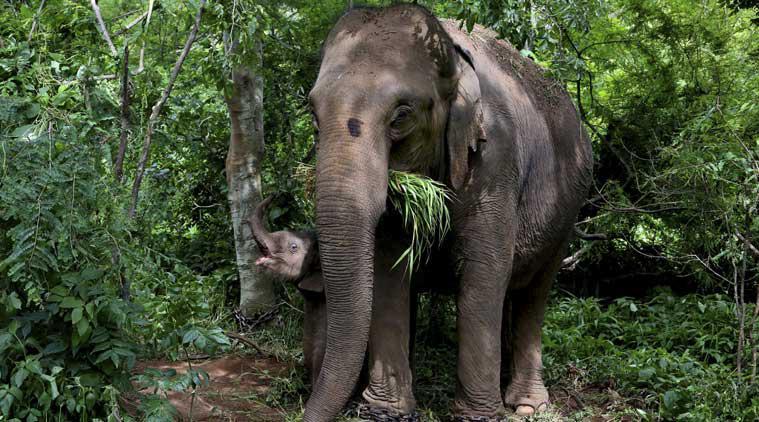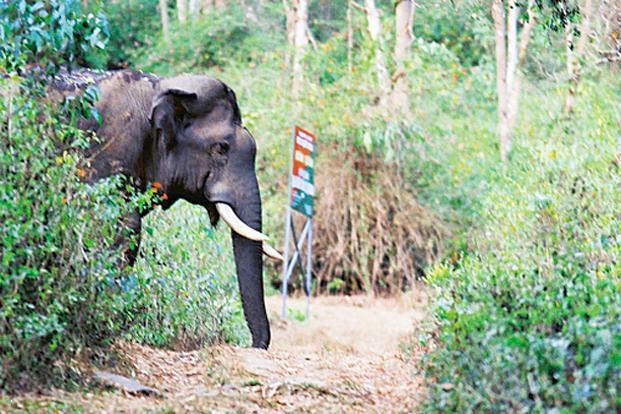The first image is the image on the left, the second image is the image on the right. Considering the images on both sides, is "An image shows a camera-facing elephant with tusks and trunk pointed downward." valid? Answer yes or no. No. The first image is the image on the left, the second image is the image on the right. Evaluate the accuracy of this statement regarding the images: "Two elephants are in the grassy wilderness.". Is it true? Answer yes or no. No. 